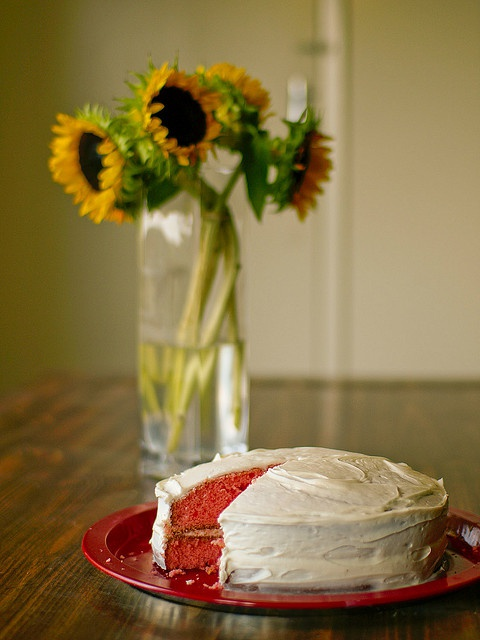Describe the objects in this image and their specific colors. I can see dining table in olive, maroon, tan, and black tones, cake in olive, tan, and lightgray tones, and vase in olive, tan, and lightgray tones in this image. 